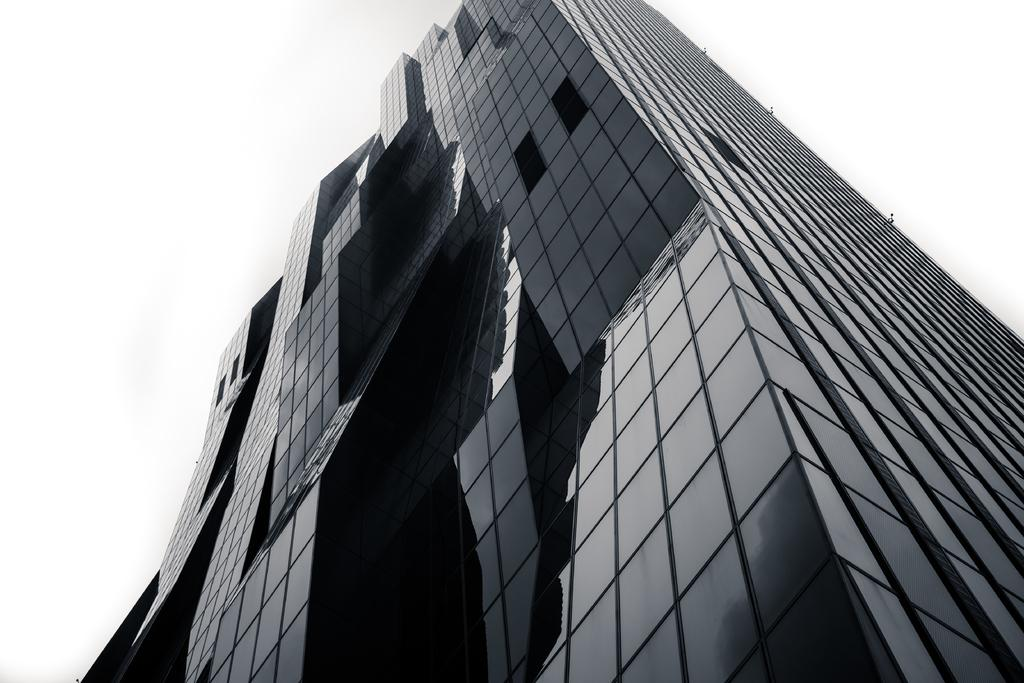What type of structure is present in the image? There is a building in the image. What can be seen in the background of the image? The sky is visible in the background of the image. What type of linen is used to cover the windows in the image? There is no information about linen or window coverings in the image. 